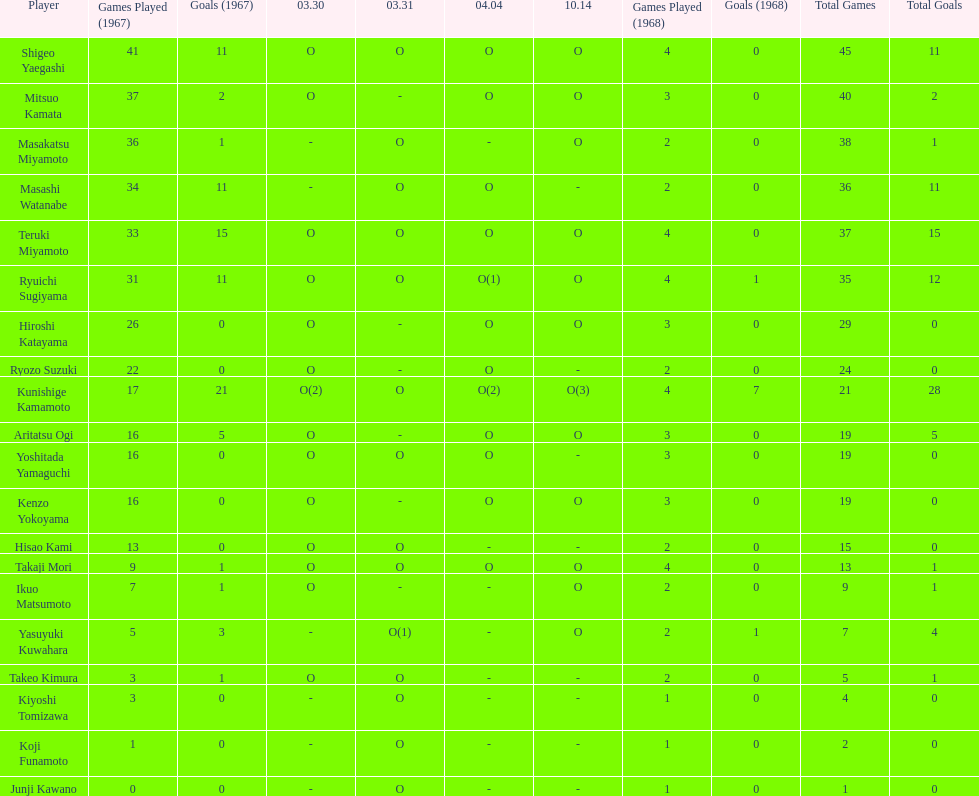Total appearances by masakatsu miyamoto? 38. 